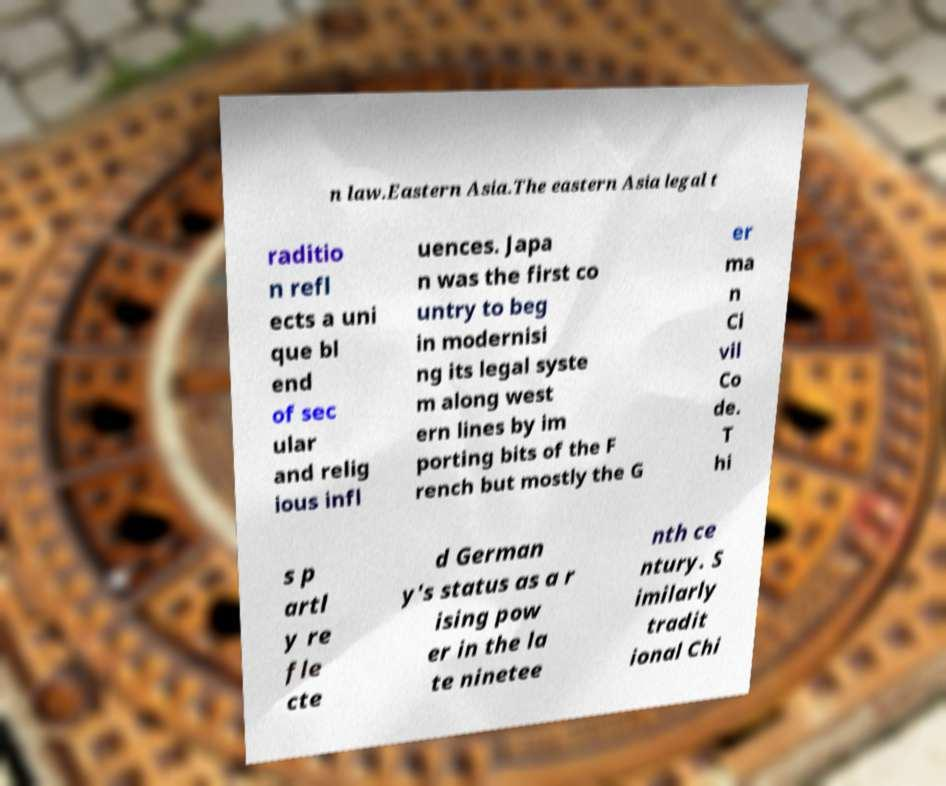Could you assist in decoding the text presented in this image and type it out clearly? n law.Eastern Asia.The eastern Asia legal t raditio n refl ects a uni que bl end of sec ular and relig ious infl uences. Japa n was the first co untry to beg in modernisi ng its legal syste m along west ern lines by im porting bits of the F rench but mostly the G er ma n Ci vil Co de. T hi s p artl y re fle cte d German y's status as a r ising pow er in the la te ninetee nth ce ntury. S imilarly tradit ional Chi 